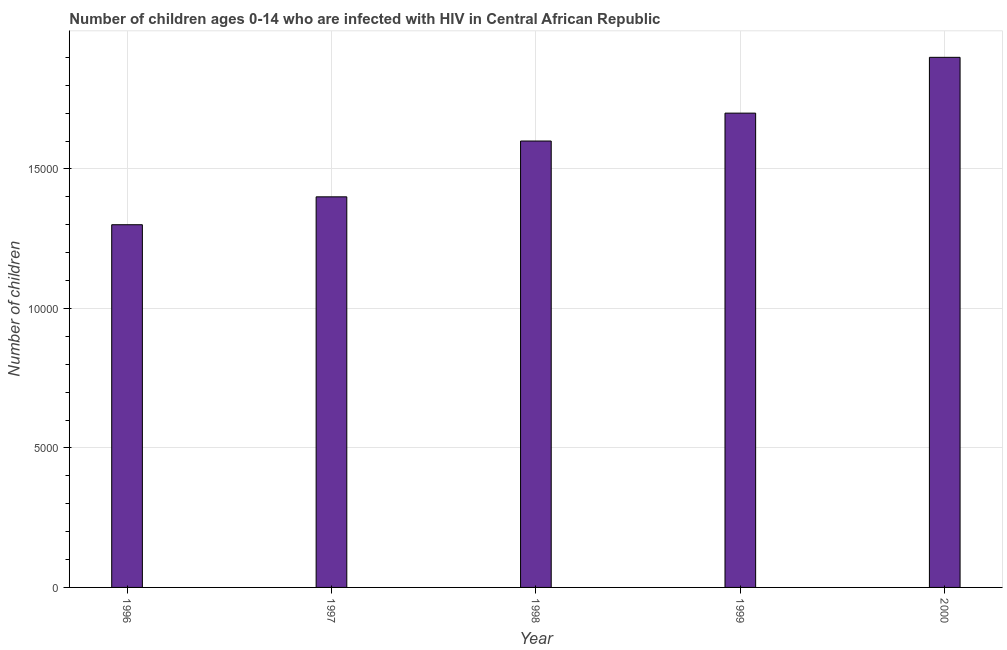What is the title of the graph?
Offer a terse response. Number of children ages 0-14 who are infected with HIV in Central African Republic. What is the label or title of the Y-axis?
Provide a succinct answer. Number of children. What is the number of children living with hiv in 1996?
Give a very brief answer. 1.30e+04. Across all years, what is the maximum number of children living with hiv?
Your answer should be very brief. 1.90e+04. Across all years, what is the minimum number of children living with hiv?
Offer a very short reply. 1.30e+04. In which year was the number of children living with hiv maximum?
Keep it short and to the point. 2000. What is the sum of the number of children living with hiv?
Your answer should be very brief. 7.90e+04. What is the difference between the number of children living with hiv in 1996 and 2000?
Offer a terse response. -6000. What is the average number of children living with hiv per year?
Your response must be concise. 1.58e+04. What is the median number of children living with hiv?
Keep it short and to the point. 1.60e+04. In how many years, is the number of children living with hiv greater than 11000 ?
Give a very brief answer. 5. Do a majority of the years between 1999 and 1998 (inclusive) have number of children living with hiv greater than 12000 ?
Provide a succinct answer. No. What is the ratio of the number of children living with hiv in 1997 to that in 2000?
Ensure brevity in your answer.  0.74. Is the number of children living with hiv in 1996 less than that in 2000?
Your answer should be compact. Yes. What is the difference between the highest and the second highest number of children living with hiv?
Your answer should be compact. 2000. What is the difference between the highest and the lowest number of children living with hiv?
Your response must be concise. 6000. How many bars are there?
Offer a terse response. 5. How many years are there in the graph?
Keep it short and to the point. 5. Are the values on the major ticks of Y-axis written in scientific E-notation?
Provide a succinct answer. No. What is the Number of children of 1996?
Your answer should be compact. 1.30e+04. What is the Number of children in 1997?
Provide a succinct answer. 1.40e+04. What is the Number of children of 1998?
Offer a very short reply. 1.60e+04. What is the Number of children in 1999?
Keep it short and to the point. 1.70e+04. What is the Number of children of 2000?
Offer a very short reply. 1.90e+04. What is the difference between the Number of children in 1996 and 1997?
Your response must be concise. -1000. What is the difference between the Number of children in 1996 and 1998?
Offer a very short reply. -3000. What is the difference between the Number of children in 1996 and 1999?
Give a very brief answer. -4000. What is the difference between the Number of children in 1996 and 2000?
Ensure brevity in your answer.  -6000. What is the difference between the Number of children in 1997 and 1998?
Your response must be concise. -2000. What is the difference between the Number of children in 1997 and 1999?
Your answer should be compact. -3000. What is the difference between the Number of children in 1997 and 2000?
Ensure brevity in your answer.  -5000. What is the difference between the Number of children in 1998 and 1999?
Offer a very short reply. -1000. What is the difference between the Number of children in 1998 and 2000?
Provide a short and direct response. -3000. What is the difference between the Number of children in 1999 and 2000?
Provide a short and direct response. -2000. What is the ratio of the Number of children in 1996 to that in 1997?
Ensure brevity in your answer.  0.93. What is the ratio of the Number of children in 1996 to that in 1998?
Ensure brevity in your answer.  0.81. What is the ratio of the Number of children in 1996 to that in 1999?
Give a very brief answer. 0.77. What is the ratio of the Number of children in 1996 to that in 2000?
Your response must be concise. 0.68. What is the ratio of the Number of children in 1997 to that in 1999?
Your answer should be very brief. 0.82. What is the ratio of the Number of children in 1997 to that in 2000?
Offer a terse response. 0.74. What is the ratio of the Number of children in 1998 to that in 1999?
Give a very brief answer. 0.94. What is the ratio of the Number of children in 1998 to that in 2000?
Provide a short and direct response. 0.84. What is the ratio of the Number of children in 1999 to that in 2000?
Your response must be concise. 0.9. 